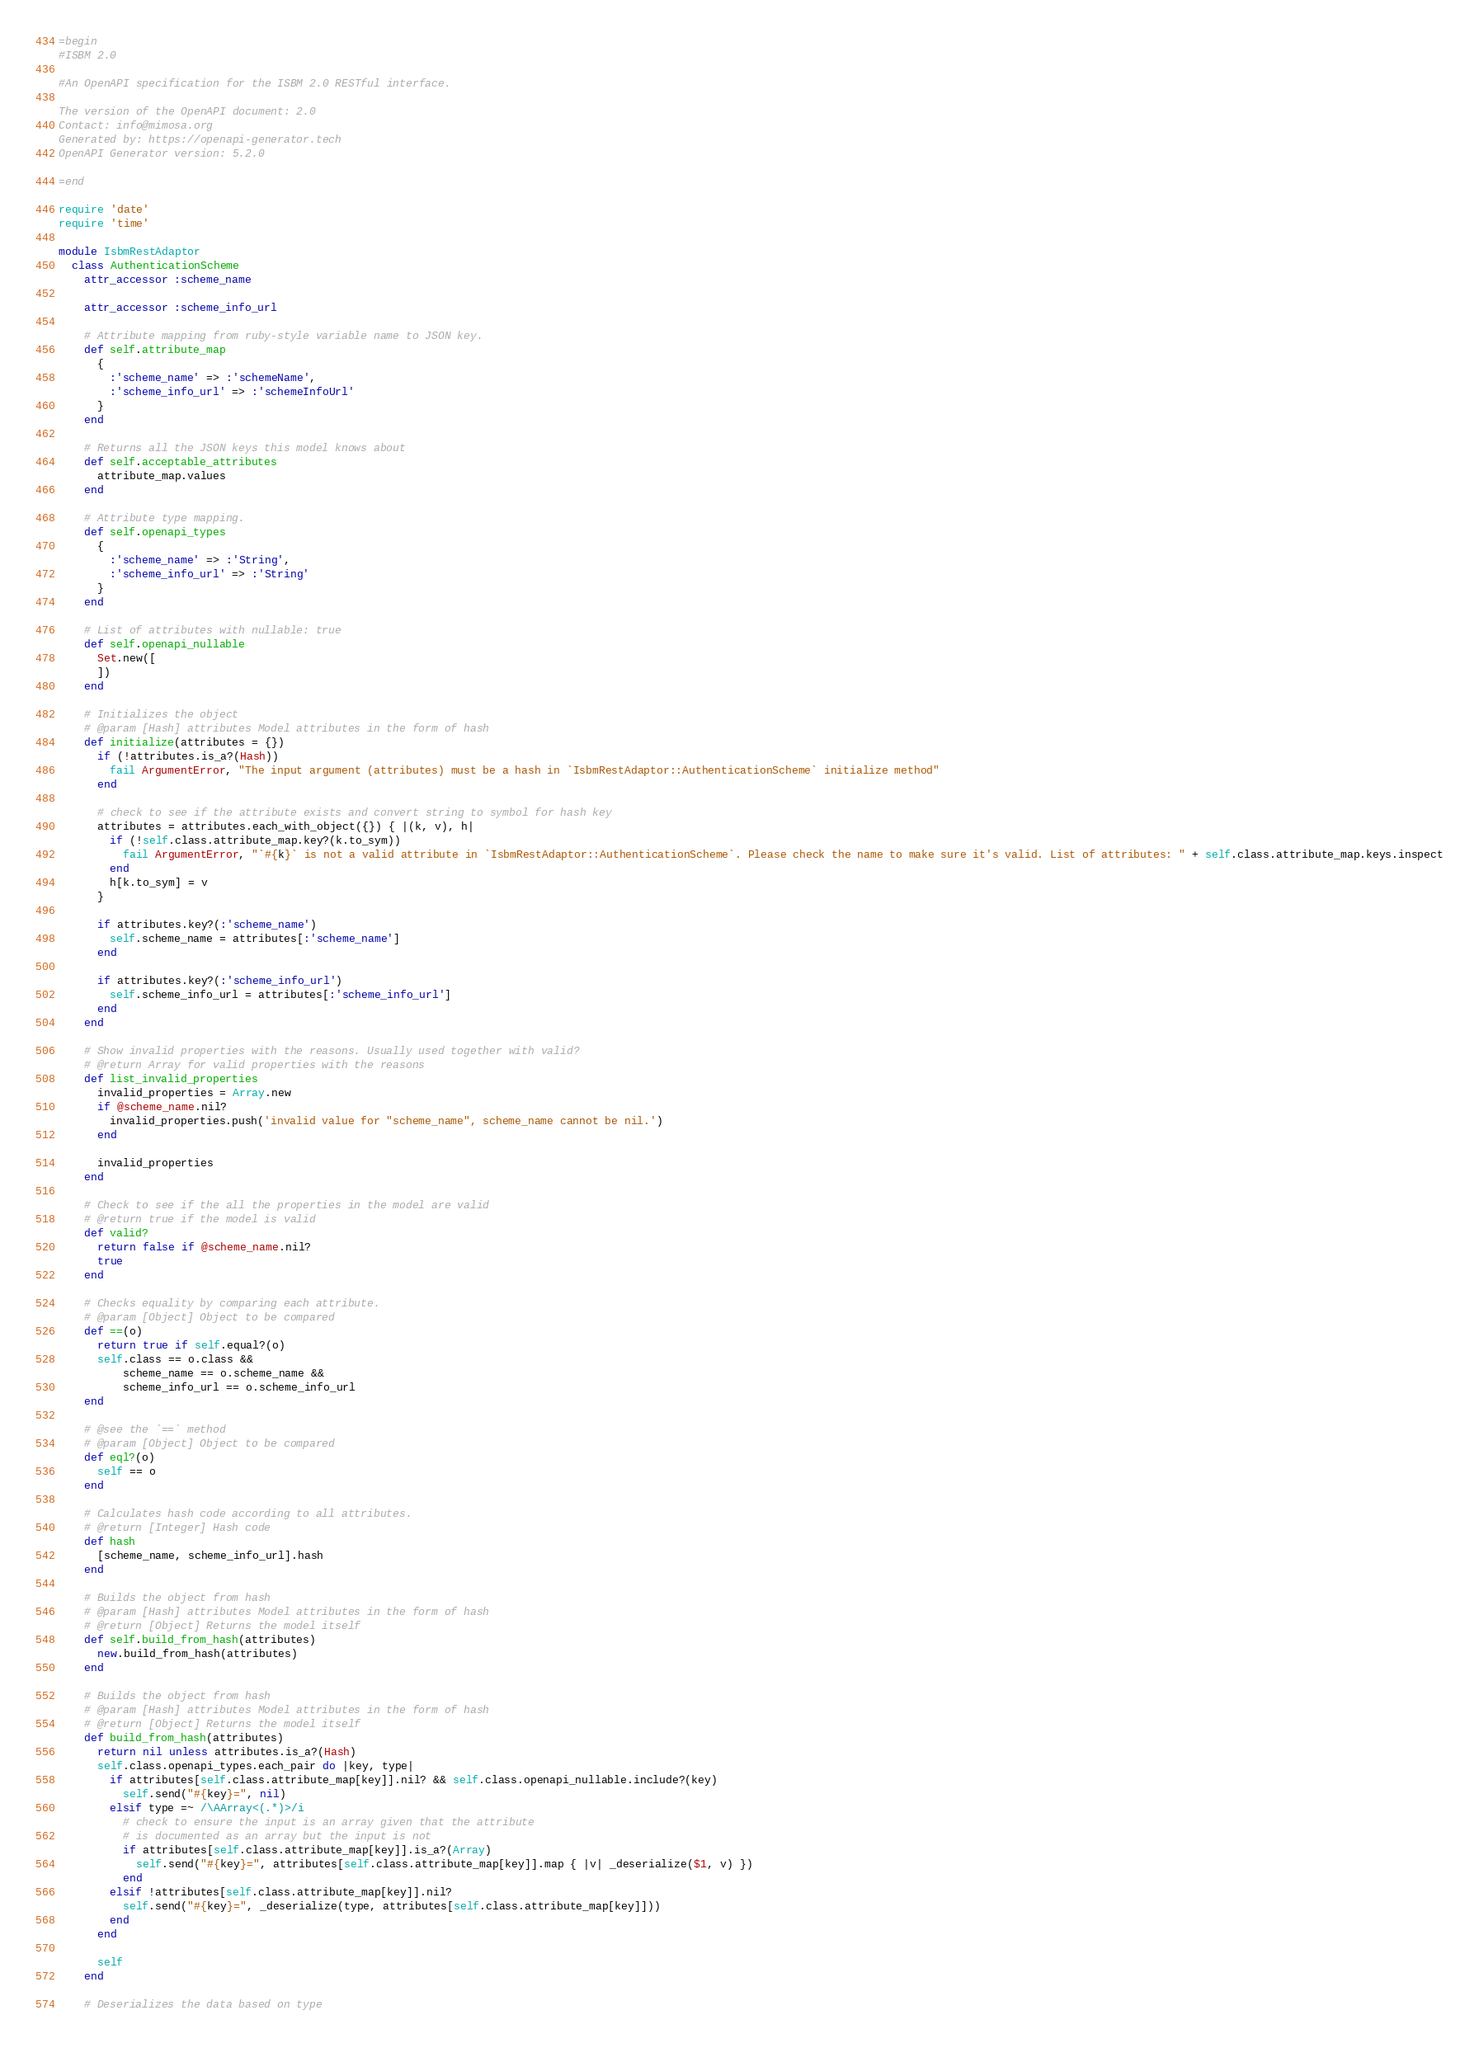<code> <loc_0><loc_0><loc_500><loc_500><_Ruby_>=begin
#ISBM 2.0

#An OpenAPI specification for the ISBM 2.0 RESTful interface.

The version of the OpenAPI document: 2.0
Contact: info@mimosa.org
Generated by: https://openapi-generator.tech
OpenAPI Generator version: 5.2.0

=end

require 'date'
require 'time'

module IsbmRestAdaptor
  class AuthenticationScheme
    attr_accessor :scheme_name

    attr_accessor :scheme_info_url

    # Attribute mapping from ruby-style variable name to JSON key.
    def self.attribute_map
      {
        :'scheme_name' => :'schemeName',
        :'scheme_info_url' => :'schemeInfoUrl'
      }
    end

    # Returns all the JSON keys this model knows about
    def self.acceptable_attributes
      attribute_map.values
    end

    # Attribute type mapping.
    def self.openapi_types
      {
        :'scheme_name' => :'String',
        :'scheme_info_url' => :'String'
      }
    end

    # List of attributes with nullable: true
    def self.openapi_nullable
      Set.new([
      ])
    end

    # Initializes the object
    # @param [Hash] attributes Model attributes in the form of hash
    def initialize(attributes = {})
      if (!attributes.is_a?(Hash))
        fail ArgumentError, "The input argument (attributes) must be a hash in `IsbmRestAdaptor::AuthenticationScheme` initialize method"
      end

      # check to see if the attribute exists and convert string to symbol for hash key
      attributes = attributes.each_with_object({}) { |(k, v), h|
        if (!self.class.attribute_map.key?(k.to_sym))
          fail ArgumentError, "`#{k}` is not a valid attribute in `IsbmRestAdaptor::AuthenticationScheme`. Please check the name to make sure it's valid. List of attributes: " + self.class.attribute_map.keys.inspect
        end
        h[k.to_sym] = v
      }

      if attributes.key?(:'scheme_name')
        self.scheme_name = attributes[:'scheme_name']
      end

      if attributes.key?(:'scheme_info_url')
        self.scheme_info_url = attributes[:'scheme_info_url']
      end
    end

    # Show invalid properties with the reasons. Usually used together with valid?
    # @return Array for valid properties with the reasons
    def list_invalid_properties
      invalid_properties = Array.new
      if @scheme_name.nil?
        invalid_properties.push('invalid value for "scheme_name", scheme_name cannot be nil.')
      end

      invalid_properties
    end

    # Check to see if the all the properties in the model are valid
    # @return true if the model is valid
    def valid?
      return false if @scheme_name.nil?
      true
    end

    # Checks equality by comparing each attribute.
    # @param [Object] Object to be compared
    def ==(o)
      return true if self.equal?(o)
      self.class == o.class &&
          scheme_name == o.scheme_name &&
          scheme_info_url == o.scheme_info_url
    end

    # @see the `==` method
    # @param [Object] Object to be compared
    def eql?(o)
      self == o
    end

    # Calculates hash code according to all attributes.
    # @return [Integer] Hash code
    def hash
      [scheme_name, scheme_info_url].hash
    end

    # Builds the object from hash
    # @param [Hash] attributes Model attributes in the form of hash
    # @return [Object] Returns the model itself
    def self.build_from_hash(attributes)
      new.build_from_hash(attributes)
    end

    # Builds the object from hash
    # @param [Hash] attributes Model attributes in the form of hash
    # @return [Object] Returns the model itself
    def build_from_hash(attributes)
      return nil unless attributes.is_a?(Hash)
      self.class.openapi_types.each_pair do |key, type|
        if attributes[self.class.attribute_map[key]].nil? && self.class.openapi_nullable.include?(key)
          self.send("#{key}=", nil)
        elsif type =~ /\AArray<(.*)>/i
          # check to ensure the input is an array given that the attribute
          # is documented as an array but the input is not
          if attributes[self.class.attribute_map[key]].is_a?(Array)
            self.send("#{key}=", attributes[self.class.attribute_map[key]].map { |v| _deserialize($1, v) })
          end
        elsif !attributes[self.class.attribute_map[key]].nil?
          self.send("#{key}=", _deserialize(type, attributes[self.class.attribute_map[key]]))
        end
      end

      self
    end

    # Deserializes the data based on type</code> 